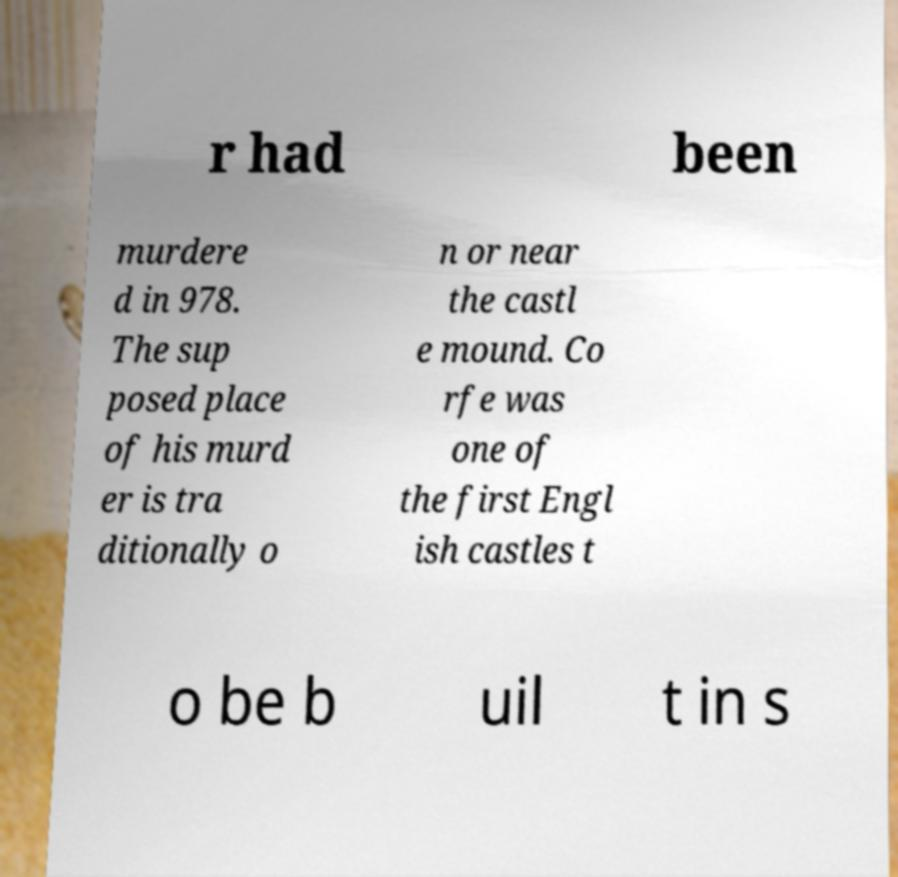Could you extract and type out the text from this image? r had been murdere d in 978. The sup posed place of his murd er is tra ditionally o n or near the castl e mound. Co rfe was one of the first Engl ish castles t o be b uil t in s 